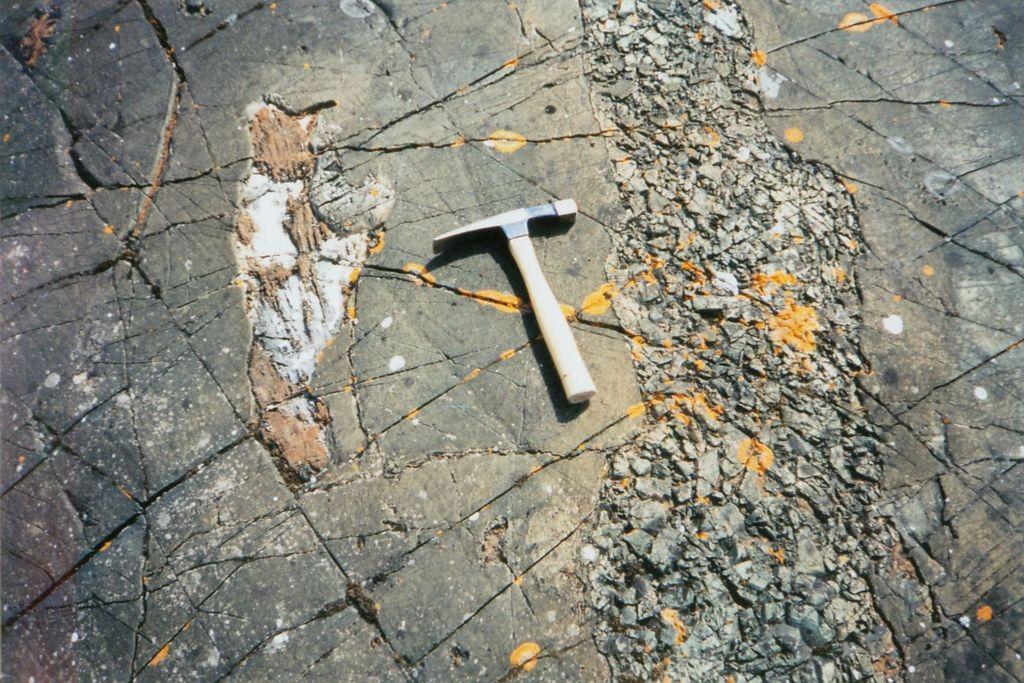Please provide a concise description of this image. In this picture there is a geologist's hammer in the center of the image, on the floor. 